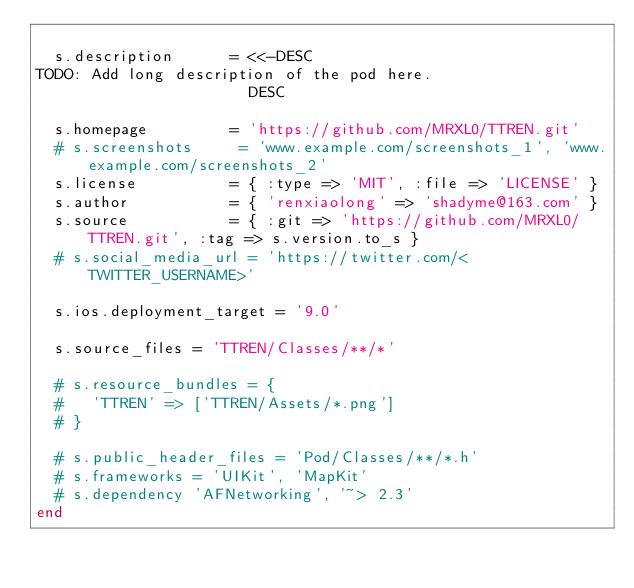<code> <loc_0><loc_0><loc_500><loc_500><_Ruby_>
  s.description      = <<-DESC
TODO: Add long description of the pod here.
                       DESC

  s.homepage         = 'https://github.com/MRXL0/TTREN.git'
  # s.screenshots     = 'www.example.com/screenshots_1', 'www.example.com/screenshots_2'
  s.license          = { :type => 'MIT', :file => 'LICENSE' }
  s.author           = { 'renxiaolong' => 'shadyme@163.com' }
  s.source           = { :git => 'https://github.com/MRXL0/TTREN.git', :tag => s.version.to_s }
  # s.social_media_url = 'https://twitter.com/<TWITTER_USERNAME>'

  s.ios.deployment_target = '9.0'

  s.source_files = 'TTREN/Classes/**/*'
  
  # s.resource_bundles = {
  #   'TTREN' => ['TTREN/Assets/*.png']
  # }

  # s.public_header_files = 'Pod/Classes/**/*.h'
  # s.frameworks = 'UIKit', 'MapKit'
  # s.dependency 'AFNetworking', '~> 2.3'
end
</code> 